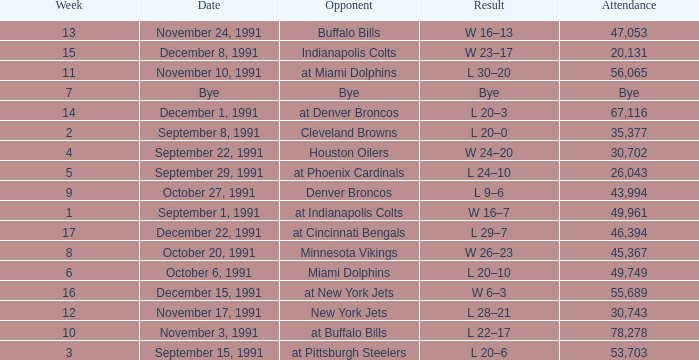Who did the Patriots play in week 4? Houston Oilers. 